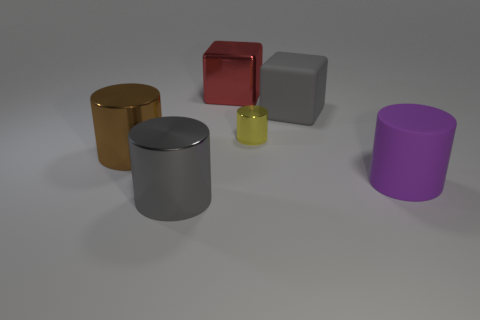If I were to arrange these objects by their heights, which object would come first? Starting with the shortest, the yellow object would come first, followed by the red, the golden cylinder, the purple cylinder, and finally the grey cylinder as the tallest. 